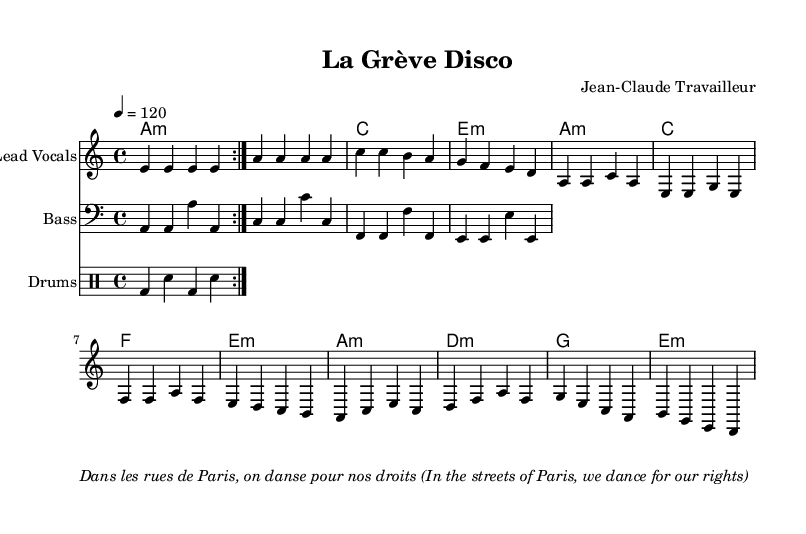What is the key signature of this piece? The key signature is indicated by the presence of the A minor key in the global section of the music, which typically has no sharps or flats.
Answer: A minor What is the time signature of the music? The time signature is found in the global section, specified as 4/4, meaning there are four beats in each measure.
Answer: 4/4 What is the tempo of the song? The tempo is stated in the global section, marked as 120 beats per minute.
Answer: 120 How many measures are in the intro? The intro consists of four measures as noted at the beginning of the melody section.
Answer: 4 What type of chords are primarily used in the chorus? The chorus includes minor chords, as denoted in the harmonies section, indicated by the "m" symbol after some chords.
Answer: Minor What is the predominant rhythm pattern used in the drum part? The drum pattern features a repetition of bass drum and snare drum beats, making a simple and danceable rhythm typical for disco music.
Answer: Bass and snare What does the italic text at the bottom signify about the song's theme? The italicized text translates to a message celebrating workers' rights, reinforcing the socio-political context of the song's disco vibe.
Answer: Celebration of workers' rights 